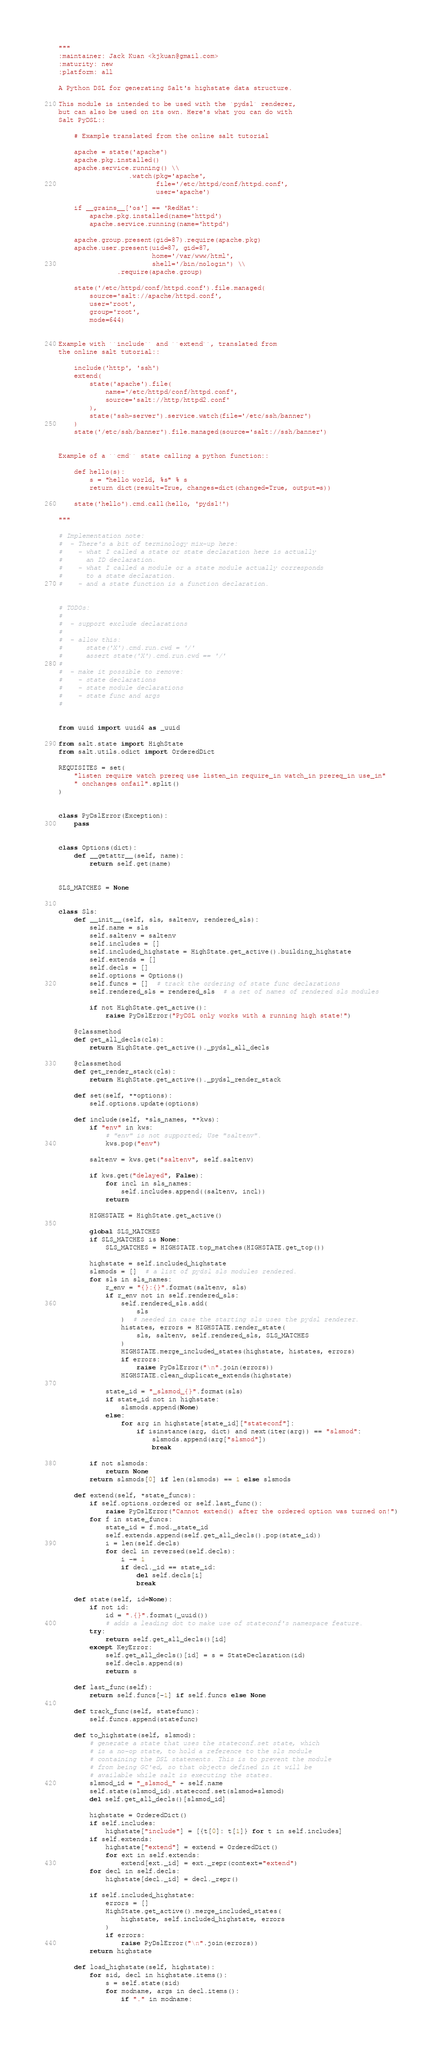<code> <loc_0><loc_0><loc_500><loc_500><_Python_>"""
:maintainer: Jack Kuan <kjkuan@gmail.com>
:maturity: new
:platform: all

A Python DSL for generating Salt's highstate data structure.

This module is intended to be used with the `pydsl` renderer,
but can also be used on its own. Here's what you can do with
Salt PyDSL::

    # Example translated from the online salt tutorial

    apache = state('apache')
    apache.pkg.installed()
    apache.service.running() \\
                  .watch(pkg='apache',
                         file='/etc/httpd/conf/httpd.conf',
                         user='apache')

    if __grains__['os'] == 'RedHat':
        apache.pkg.installed(name='httpd')
        apache.service.running(name='httpd')

    apache.group.present(gid=87).require(apache.pkg)
    apache.user.present(uid=87, gid=87,
                        home='/var/www/html',
                        shell='/bin/nologin') \\
               .require(apache.group)

    state('/etc/httpd/conf/httpd.conf').file.managed(
        source='salt://apache/httpd.conf',
        user='root',
        group='root',
        mode=644)


Example with ``include`` and ``extend``, translated from
the online salt tutorial::

    include('http', 'ssh')
    extend(
        state('apache').file(
            name='/etc/httpd/conf/httpd.conf',
            source='salt://http/httpd2.conf'
        ),
        state('ssh-server').service.watch(file='/etc/ssh/banner')
    )
    state('/etc/ssh/banner').file.managed(source='salt://ssh/banner')


Example of a ``cmd`` state calling a python function::

    def hello(s):
        s = "hello world, %s" % s
        return dict(result=True, changes=dict(changed=True, output=s))

    state('hello').cmd.call(hello, 'pydsl!')

"""

# Implementation note:
#  - There's a bit of terminology mix-up here:
#    - what I called a state or state declaration here is actually
#      an ID declaration.
#    - what I called a module or a state module actually corresponds
#      to a state declaration.
#    - and a state function is a function declaration.


# TODOs:
#
#  - support exclude declarations
#
#  - allow this:
#      state('X').cmd.run.cwd = '/'
#      assert state('X').cmd.run.cwd == '/'
#
#  - make it possible to remove:
#    - state declarations
#    - state module declarations
#    - state func and args
#


from uuid import uuid4 as _uuid

from salt.state import HighState
from salt.utils.odict import OrderedDict

REQUISITES = set(
    "listen require watch prereq use listen_in require_in watch_in prereq_in use_in"
    " onchanges onfail".split()
)


class PyDslError(Exception):
    pass


class Options(dict):
    def __getattr__(self, name):
        return self.get(name)


SLS_MATCHES = None


class Sls:
    def __init__(self, sls, saltenv, rendered_sls):
        self.name = sls
        self.saltenv = saltenv
        self.includes = []
        self.included_highstate = HighState.get_active().building_highstate
        self.extends = []
        self.decls = []
        self.options = Options()
        self.funcs = []  # track the ordering of state func declarations
        self.rendered_sls = rendered_sls  # a set of names of rendered sls modules

        if not HighState.get_active():
            raise PyDslError("PyDSL only works with a running high state!")

    @classmethod
    def get_all_decls(cls):
        return HighState.get_active()._pydsl_all_decls

    @classmethod
    def get_render_stack(cls):
        return HighState.get_active()._pydsl_render_stack

    def set(self, **options):
        self.options.update(options)

    def include(self, *sls_names, **kws):
        if "env" in kws:
            # "env" is not supported; Use "saltenv".
            kws.pop("env")

        saltenv = kws.get("saltenv", self.saltenv)

        if kws.get("delayed", False):
            for incl in sls_names:
                self.includes.append((saltenv, incl))
            return

        HIGHSTATE = HighState.get_active()

        global SLS_MATCHES
        if SLS_MATCHES is None:
            SLS_MATCHES = HIGHSTATE.top_matches(HIGHSTATE.get_top())

        highstate = self.included_highstate
        slsmods = []  # a list of pydsl sls modules rendered.
        for sls in sls_names:
            r_env = "{}:{}".format(saltenv, sls)
            if r_env not in self.rendered_sls:
                self.rendered_sls.add(
                    sls
                )  # needed in case the starting sls uses the pydsl renderer.
                histates, errors = HIGHSTATE.render_state(
                    sls, saltenv, self.rendered_sls, SLS_MATCHES
                )
                HIGHSTATE.merge_included_states(highstate, histates, errors)
                if errors:
                    raise PyDslError("\n".join(errors))
                HIGHSTATE.clean_duplicate_extends(highstate)

            state_id = "_slsmod_{}".format(sls)
            if state_id not in highstate:
                slsmods.append(None)
            else:
                for arg in highstate[state_id]["stateconf"]:
                    if isinstance(arg, dict) and next(iter(arg)) == "slsmod":
                        slsmods.append(arg["slsmod"])
                        break

        if not slsmods:
            return None
        return slsmods[0] if len(slsmods) == 1 else slsmods

    def extend(self, *state_funcs):
        if self.options.ordered or self.last_func():
            raise PyDslError("Cannot extend() after the ordered option was turned on!")
        for f in state_funcs:
            state_id = f.mod._state_id
            self.extends.append(self.get_all_decls().pop(state_id))
            i = len(self.decls)
            for decl in reversed(self.decls):
                i -= 1
                if decl._id == state_id:
                    del self.decls[i]
                    break

    def state(self, id=None):
        if not id:
            id = ".{}".format(_uuid())
            # adds a leading dot to make use of stateconf's namespace feature.
        try:
            return self.get_all_decls()[id]
        except KeyError:
            self.get_all_decls()[id] = s = StateDeclaration(id)
            self.decls.append(s)
            return s

    def last_func(self):
        return self.funcs[-1] if self.funcs else None

    def track_func(self, statefunc):
        self.funcs.append(statefunc)

    def to_highstate(self, slsmod):
        # generate a state that uses the stateconf.set state, which
        # is a no-op state, to hold a reference to the sls module
        # containing the DSL statements. This is to prevent the module
        # from being GC'ed, so that objects defined in it will be
        # available while salt is executing the states.
        slsmod_id = "_slsmod_" + self.name
        self.state(slsmod_id).stateconf.set(slsmod=slsmod)
        del self.get_all_decls()[slsmod_id]

        highstate = OrderedDict()
        if self.includes:
            highstate["include"] = [{t[0]: t[1]} for t in self.includes]
        if self.extends:
            highstate["extend"] = extend = OrderedDict()
            for ext in self.extends:
                extend[ext._id] = ext._repr(context="extend")
        for decl in self.decls:
            highstate[decl._id] = decl._repr()

        if self.included_highstate:
            errors = []
            HighState.get_active().merge_included_states(
                highstate, self.included_highstate, errors
            )
            if errors:
                raise PyDslError("\n".join(errors))
        return highstate

    def load_highstate(self, highstate):
        for sid, decl in highstate.items():
            s = self.state(sid)
            for modname, args in decl.items():
                if "." in modname:</code> 